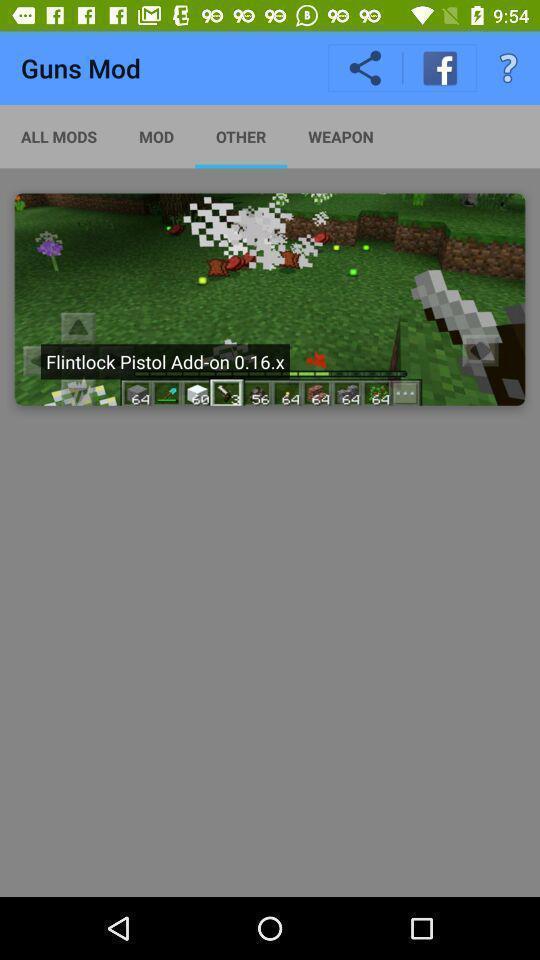What is the overall content of this screenshot? Page of a gaming app. 